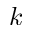<formula> <loc_0><loc_0><loc_500><loc_500>k</formula> 